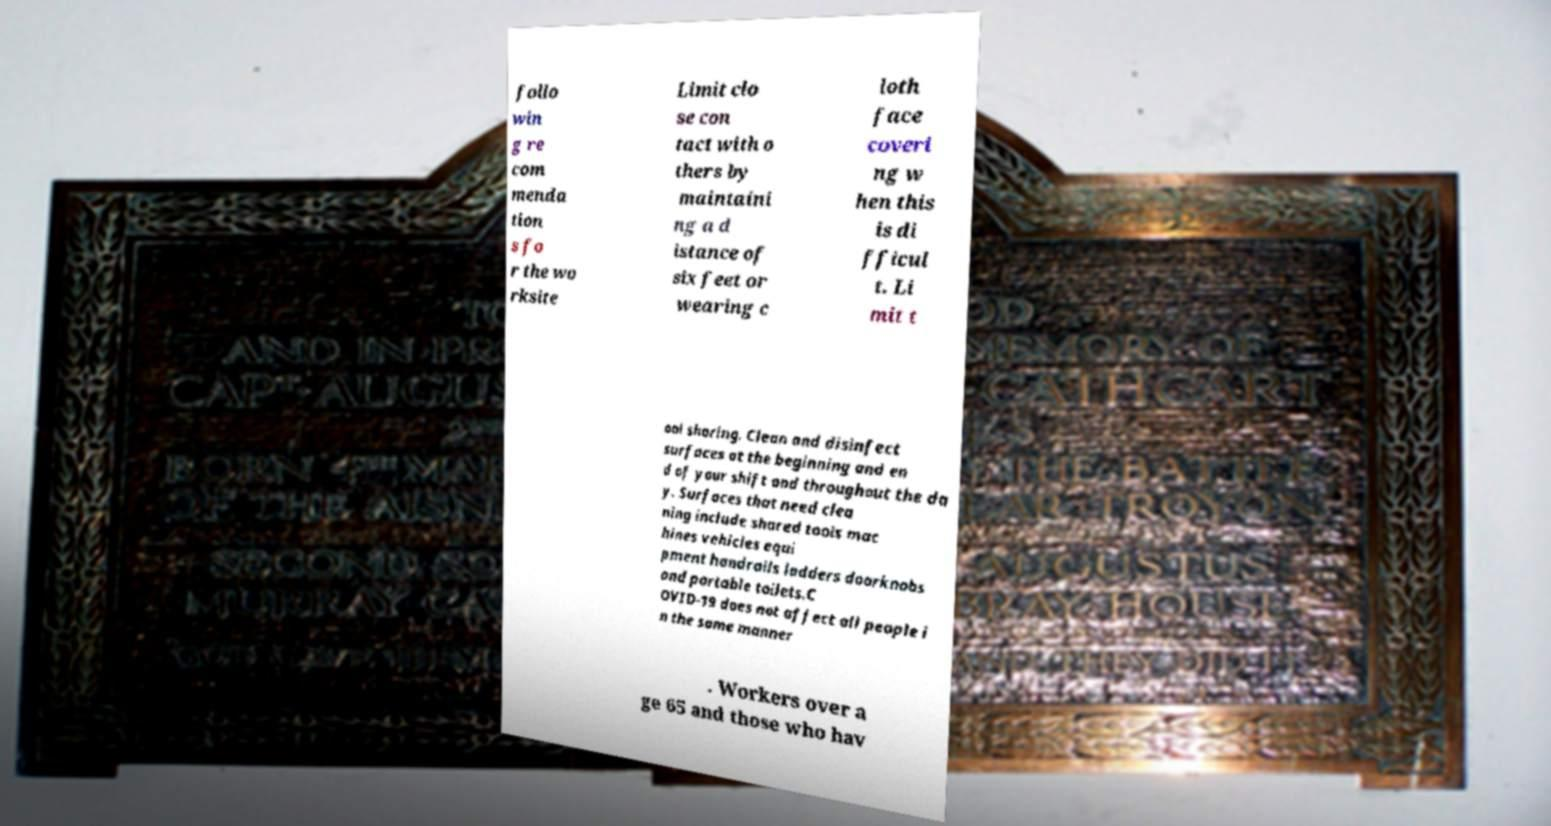For documentation purposes, I need the text within this image transcribed. Could you provide that? follo win g re com menda tion s fo r the wo rksite Limit clo se con tact with o thers by maintaini ng a d istance of six feet or wearing c loth face coveri ng w hen this is di fficul t. Li mit t ool sharing. Clean and disinfect surfaces at the beginning and en d of your shift and throughout the da y. Surfaces that need clea ning include shared tools mac hines vehicles equi pment handrails ladders doorknobs and portable toilets.C OVID-19 does not affect all people i n the same manner . Workers over a ge 65 and those who hav 